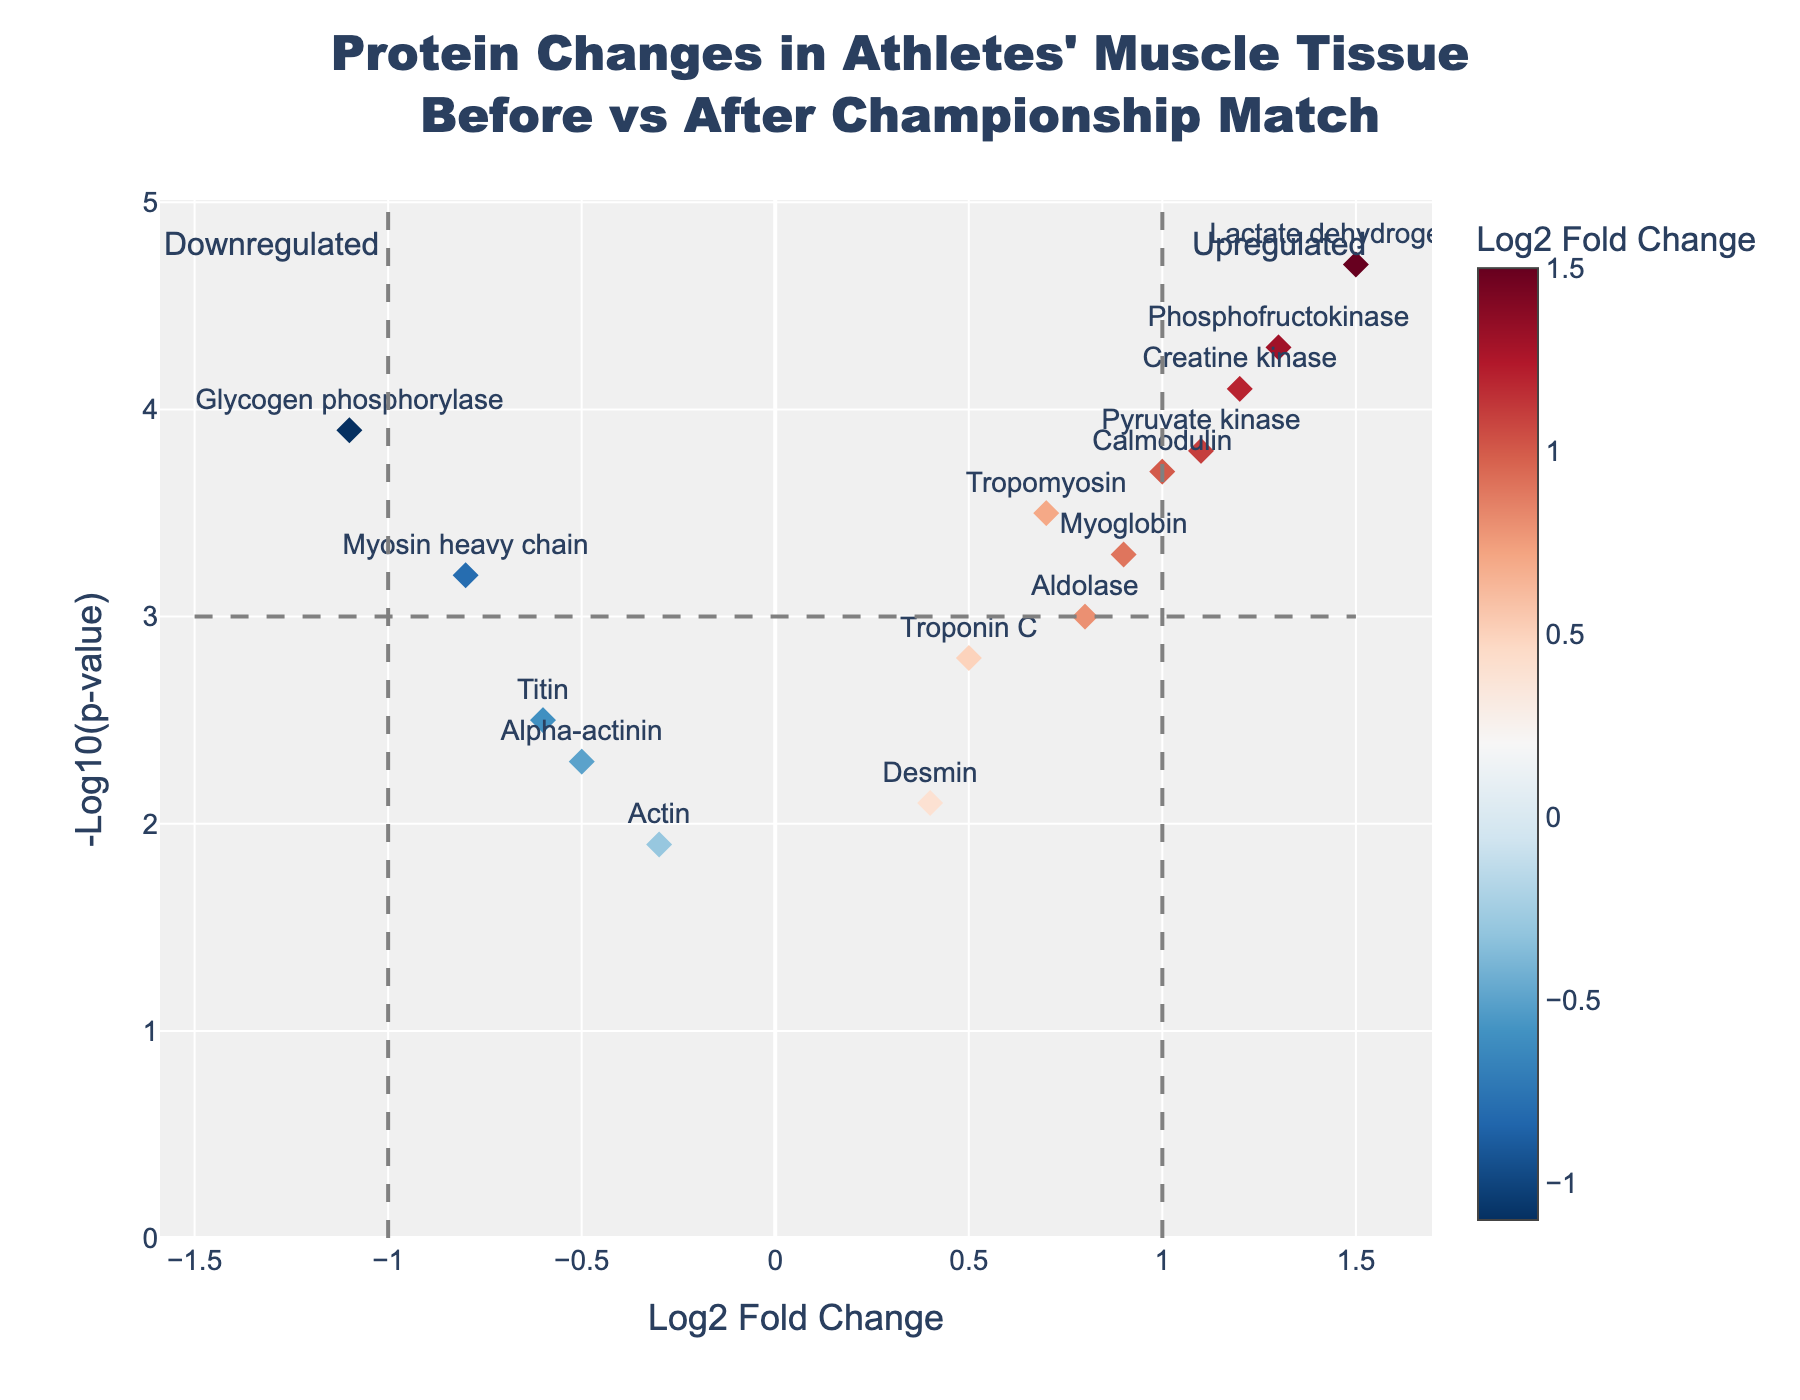What's the title of the plot? The title is displayed at the top of the figure. It reads, "Protein Changes in Athletes' Muscle Tissue Before vs After Championship Match".
Answer: Protein Changes in Athletes' Muscle Tissue Before vs After Championship Match How many proteins show upregulation after the championship match? Upregulation is indicated by positive Log2 Fold Change values. From the plot, count the number of data points (proteins) with positive Log2 Fold Change values. These are Creatine kinase, Troponin C, Tropomyosin, Lactate dehydrogenase, Myoglobin, Calmodulin, Aldolase, Phosphofructokinase, and Pyruvate kinase, which makes 9 proteins in total.
Answer: 9 Which protein has the highest negative log10 p-value? The highest point on the y-axis of the plot represents the protein with the highest negative log10 p-value. Lactate dehydrogenase occupies the highest position on the y-axis with a value of 4.7.
Answer: Lactate dehydrogenase What is the log2 fold change and negative log10 p-value for Glycogen phosphorylase? Look for the data point labeled "Glycogen phosphorylase" on the plot. The hover text or position on the x and y axes gives the values: Log2 Fold Change is -1.1 and Negative Log10 P-Value is 3.9.
Answer: -1.1, 3.9 Which proteins are annotated as 'Downregulated'? Downregulated proteins are those with Log2 Fold Change < -1. Identify data points left of the dashed line at x = -1. The protein in this region is Glycogen phosphorylase.
Answer: Glycogen phosphorylase What is the range of log2 fold changes for the proteins shown? Identify the minimum and maximum x-values on the plot. The most leftward and rightward proteins correspond to log2 fold changes of approximately -1.1 (Glycogen phosphorylase) and 1.5 (Lactate dehydrogenase) respectively, making the range from -1.1 to 1.5.
Answer: -1.1 to 1.5 Which proteins have a negative log10 p-value greater than 4.0? Scan the y-axis for points above 4.0. The proteins meeting this threshold are Creatine kinase, Glycogen phosphorylase, Lactate dehydrogenase, and Phosphofructokinase.
Answer: Creatine kinase, Glycogen phosphorylase, Lactate dehydrogenase, Phosphofructokinase What is the approximate p-value of Desmin? The y-axis represents the negative log10 p-value. For Desmin, it has a negative log10 p-value of about 2.1. Convert to p-value: 10^(-2.1). The approximate p-value is 0.0079.
Answer: 0.0079 